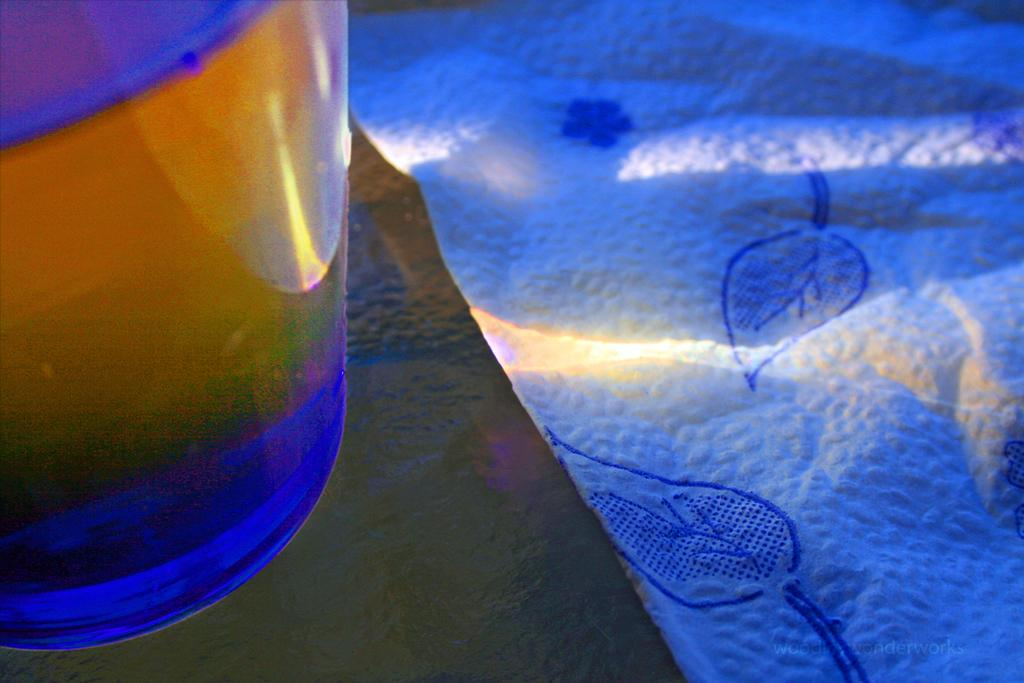What can be seen on the left side of the image? There is a glass object on the left side of the image. What is the glass object placed on? The glass object is on a black surface. What other object is present in the image? There is a cloth in the image. Is there any text or marking in the image? Yes, there is a watermark in the bottom right corner of the image. What type of space-related object can be seen in the image? There is no space-related object present in the image. How does the fire affect the glass object in the image? There is no fire present in the image, so it cannot affect the glass object. 